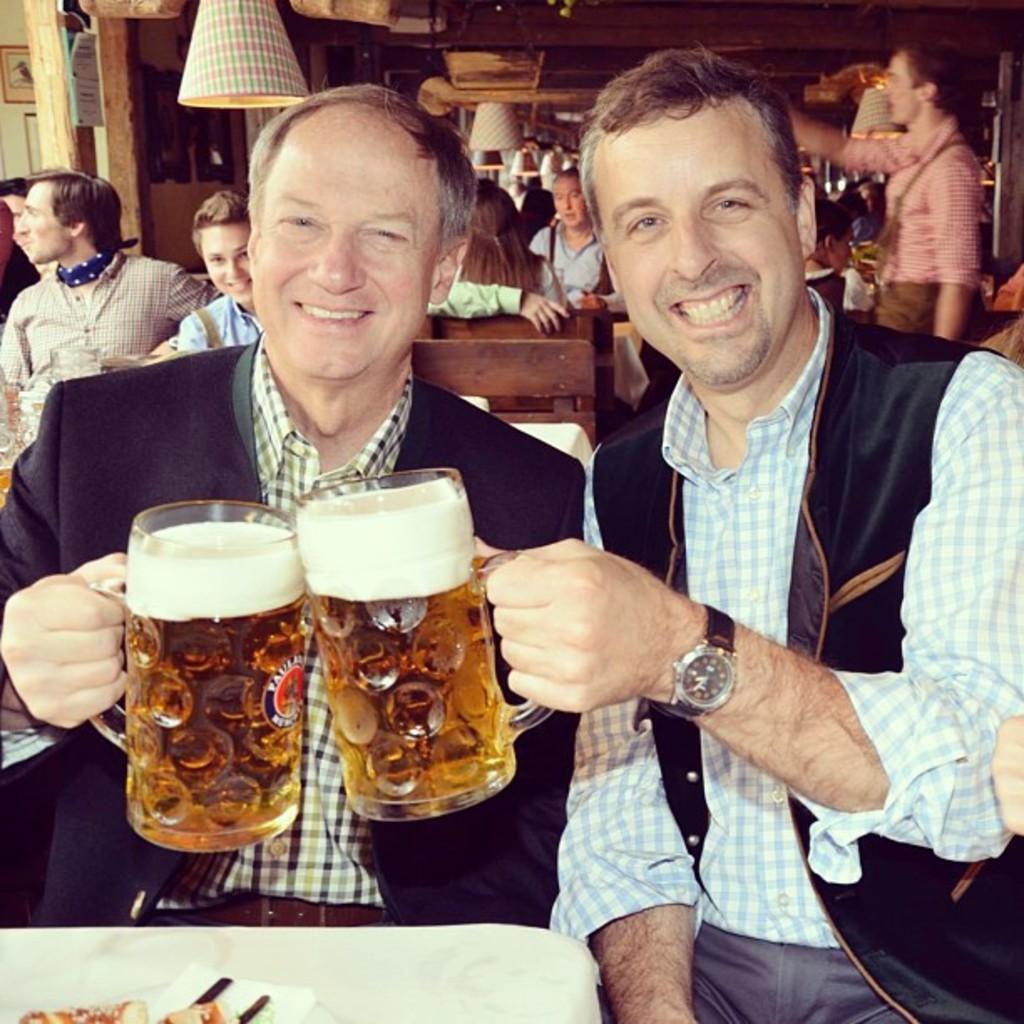Please provide a concise description of this image. This 2 persons are sitting on a chair and holds a glass with liquid. We can able to see many persons sitting on a chair. This person is standing. This 2 persons holds a smile. 